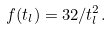<formula> <loc_0><loc_0><loc_500><loc_500>f ( t _ { l } ) = 3 2 / t _ { l } ^ { 2 } .</formula> 